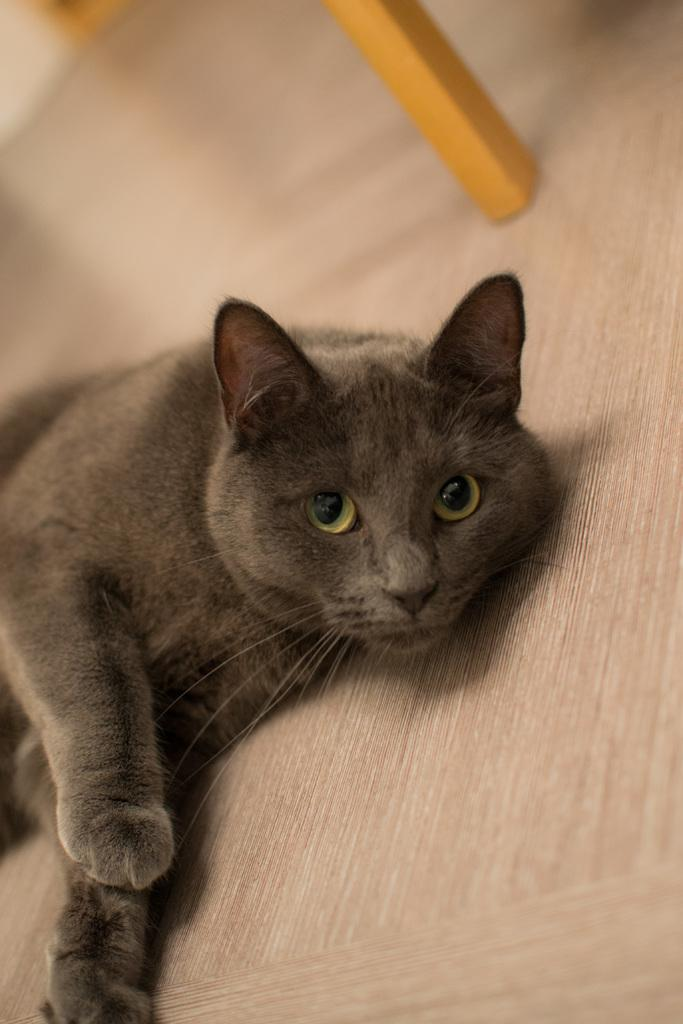What type of animal is in the image? There is a cat in the image. What color is the cat? The cat is black in color. What can be seen in the background of the image? There is a floor and wood visible in the background of the image. Can you see any pumpkins in the image? There are no pumpkins present in the image. What type of ocean can be seen in the image? There is no ocean present in the image. 